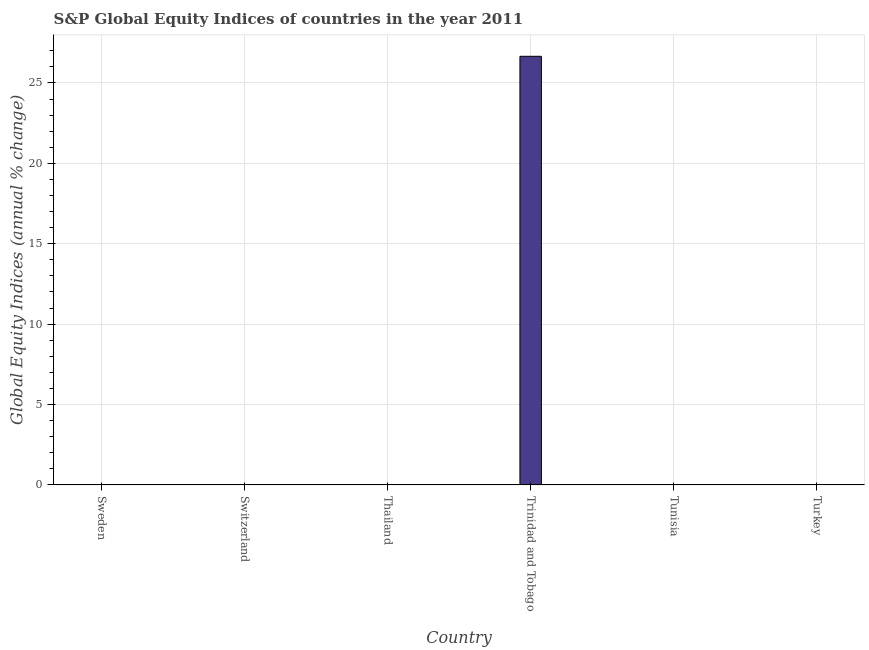Does the graph contain any zero values?
Your answer should be very brief. Yes. What is the title of the graph?
Offer a very short reply. S&P Global Equity Indices of countries in the year 2011. What is the label or title of the Y-axis?
Your answer should be very brief. Global Equity Indices (annual % change). Across all countries, what is the maximum s&p global equity indices?
Offer a very short reply. 26.66. Across all countries, what is the minimum s&p global equity indices?
Provide a short and direct response. 0. In which country was the s&p global equity indices maximum?
Give a very brief answer. Trinidad and Tobago. What is the sum of the s&p global equity indices?
Your response must be concise. 26.66. What is the average s&p global equity indices per country?
Ensure brevity in your answer.  4.44. What is the median s&p global equity indices?
Give a very brief answer. 0. What is the difference between the highest and the lowest s&p global equity indices?
Ensure brevity in your answer.  26.66. In how many countries, is the s&p global equity indices greater than the average s&p global equity indices taken over all countries?
Provide a short and direct response. 1. How many bars are there?
Provide a succinct answer. 1. How many countries are there in the graph?
Offer a very short reply. 6. What is the difference between two consecutive major ticks on the Y-axis?
Provide a succinct answer. 5. What is the Global Equity Indices (annual % change) of Switzerland?
Offer a terse response. 0. What is the Global Equity Indices (annual % change) in Thailand?
Provide a succinct answer. 0. What is the Global Equity Indices (annual % change) of Trinidad and Tobago?
Make the answer very short. 26.66. 